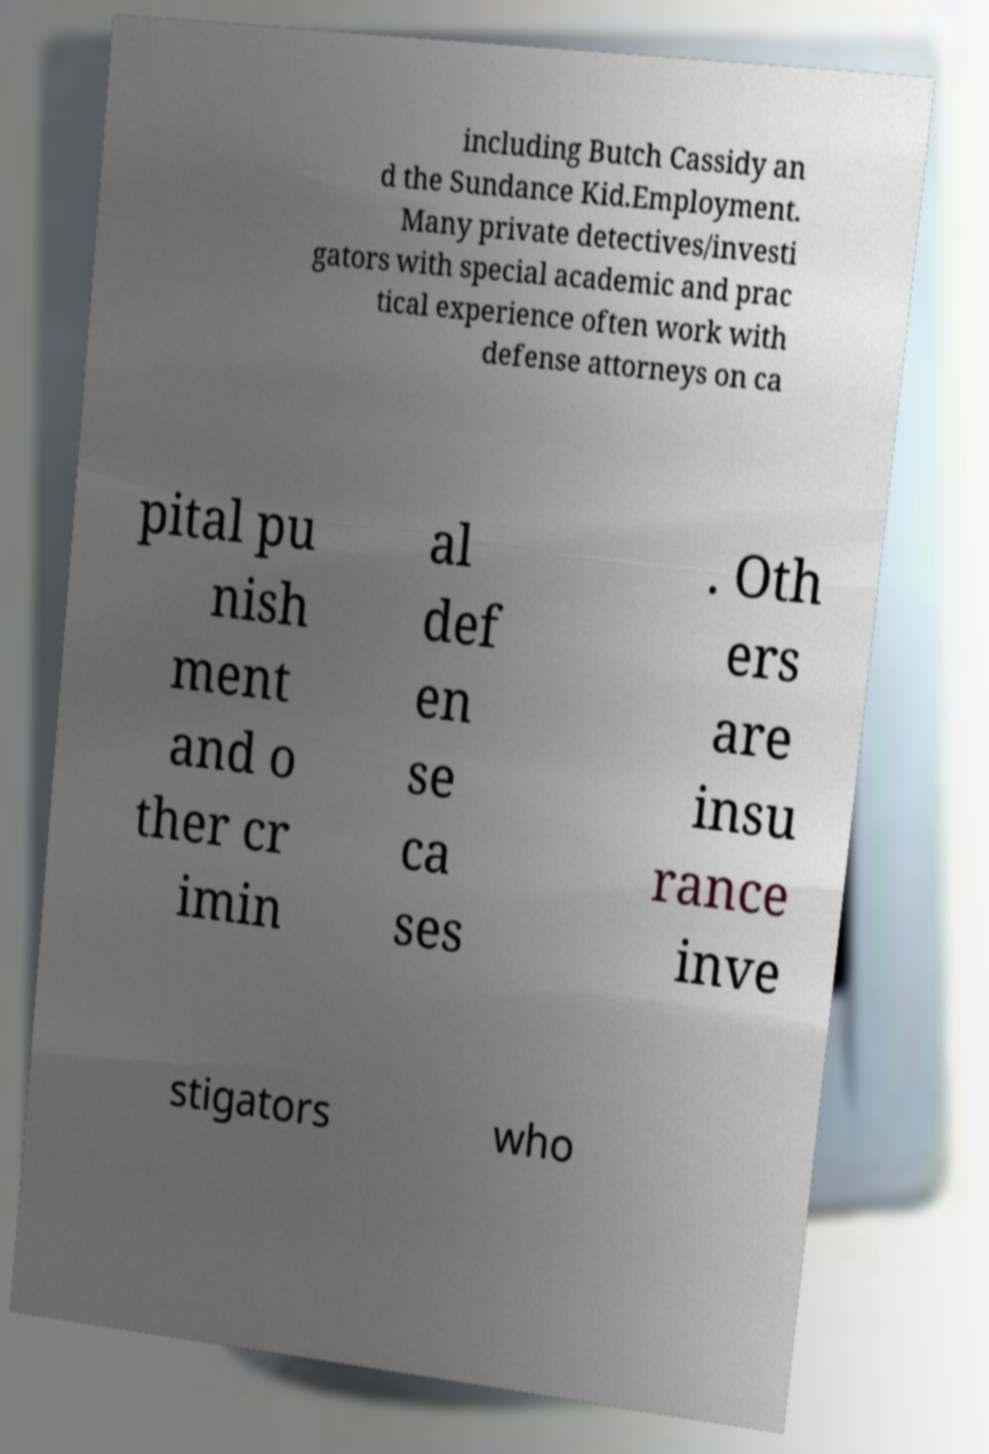I need the written content from this picture converted into text. Can you do that? including Butch Cassidy an d the Sundance Kid.Employment. Many private detectives/investi gators with special academic and prac tical experience often work with defense attorneys on ca pital pu nish ment and o ther cr imin al def en se ca ses . Oth ers are insu rance inve stigators who 